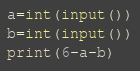<code> <loc_0><loc_0><loc_500><loc_500><_Cython_>a=int(input())
b=int(input())
print(6-a-b)</code> 